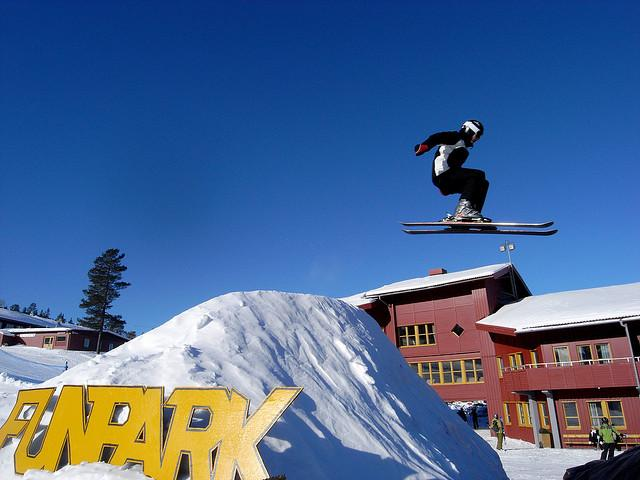What type of sign is shown? funpark 